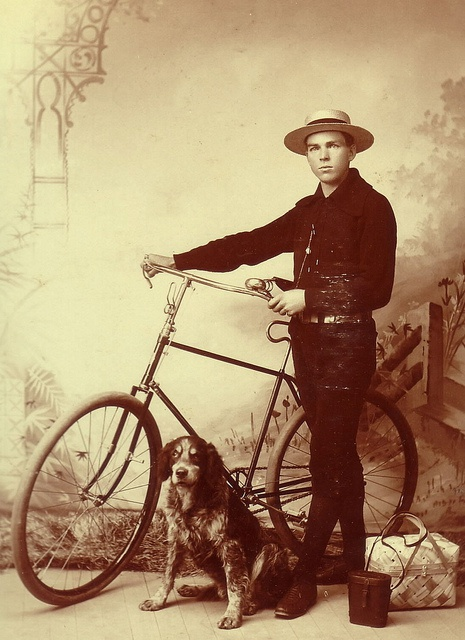Describe the objects in this image and their specific colors. I can see bicycle in khaki, maroon, gray, and tan tones, people in khaki, maroon, and gray tones, dog in khaki, maroon, gray, and tan tones, and handbag in khaki, gray, maroon, and tan tones in this image. 